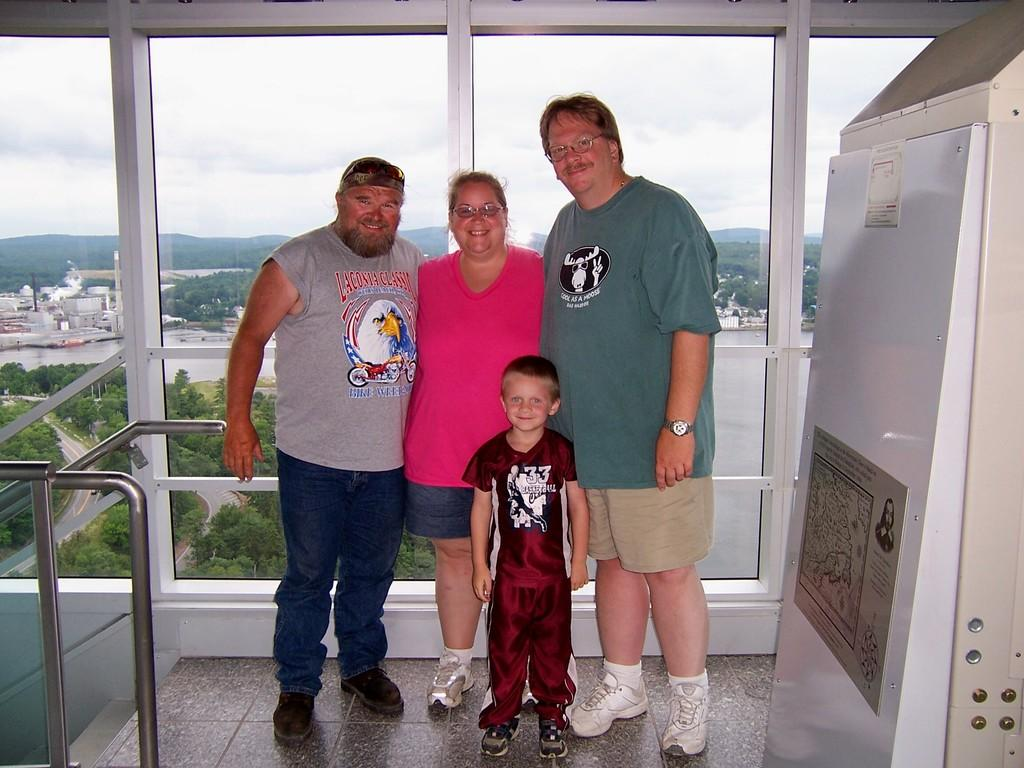What are the people in the image doing? The people in the image are taking a picture. Can you describe the setting in which the people are taking the picture? There is a glass window visible in the image, which suggests that the people might be indoors or near a building. What type of ice can be seen melting in the hands of the people in the image? There is no ice present in the image; the people are taking a picture. 